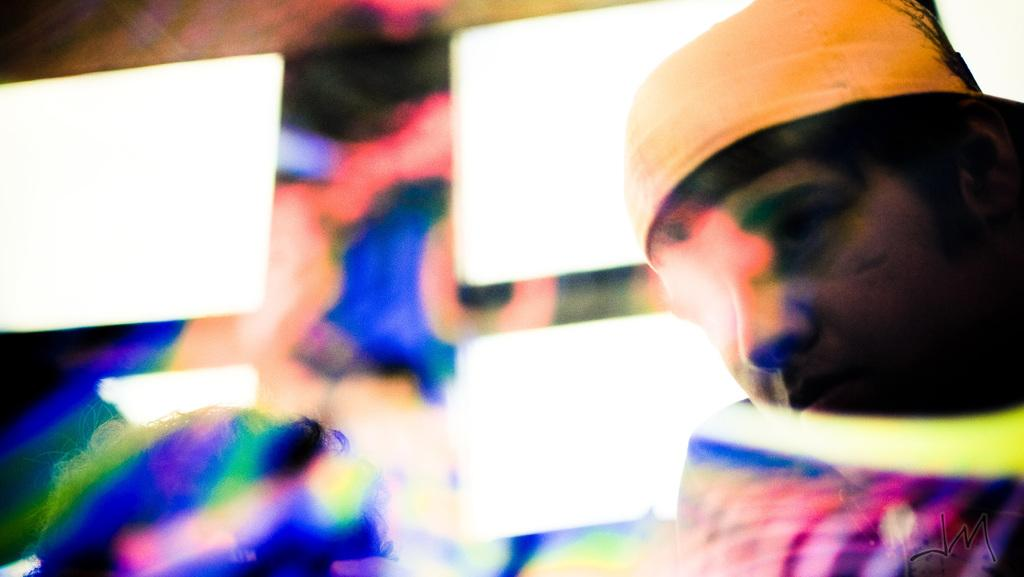What is the main subject on the right side of the picture? There is a person's face on the right side of the picture. What can be observed about the rest of the picture? The remaining portion of the picture is colorful. What is the weight of the star in the picture? There is no star present in the picture, so it is not possible to determine its weight. 